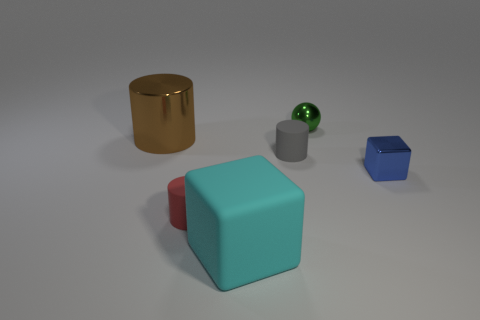How many objects are there and can you describe their shapes? There are five objects in the image: a gold cylinder with a reflective surface, a red sphere with a glossy finish, a large aqua blue cube, a small gray cylinder with a matte texture, and a dark blue rhombic polyhedron, an irregular four-sided geometric shape. 